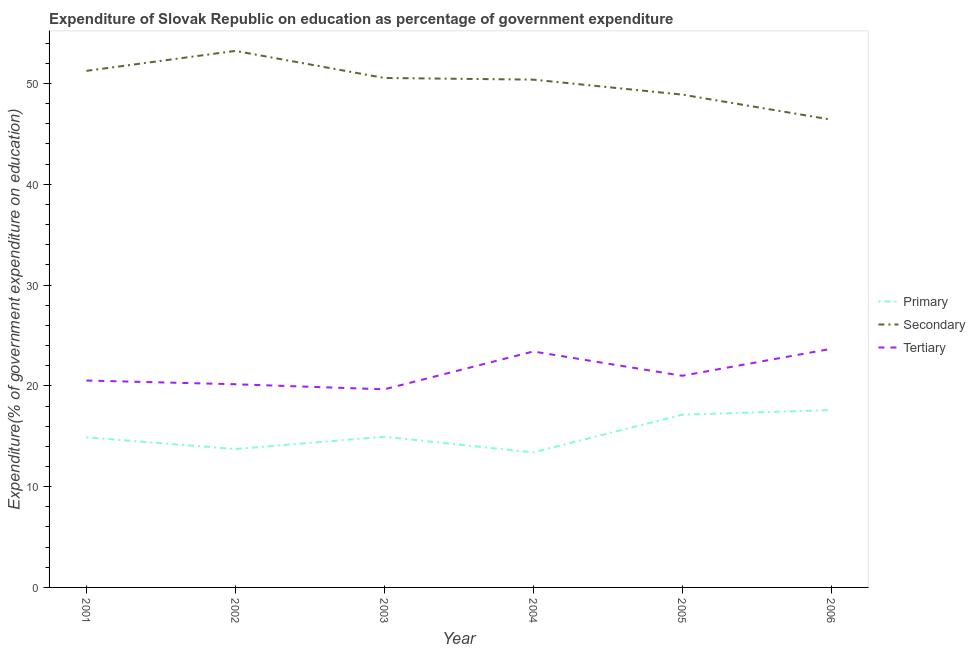Does the line corresponding to expenditure on tertiary education intersect with the line corresponding to expenditure on secondary education?
Make the answer very short. No. Is the number of lines equal to the number of legend labels?
Give a very brief answer. Yes. What is the expenditure on primary education in 2004?
Keep it short and to the point. 13.4. Across all years, what is the maximum expenditure on primary education?
Give a very brief answer. 17.6. Across all years, what is the minimum expenditure on secondary education?
Your answer should be very brief. 46.42. In which year was the expenditure on primary education minimum?
Provide a short and direct response. 2004. What is the total expenditure on tertiary education in the graph?
Offer a very short reply. 128.44. What is the difference between the expenditure on secondary education in 2002 and that in 2004?
Provide a short and direct response. 2.85. What is the difference between the expenditure on tertiary education in 2001 and the expenditure on secondary education in 2002?
Ensure brevity in your answer.  -32.71. What is the average expenditure on secondary education per year?
Provide a succinct answer. 50.12. In the year 2002, what is the difference between the expenditure on tertiary education and expenditure on secondary education?
Offer a terse response. -33.08. In how many years, is the expenditure on primary education greater than 14 %?
Your answer should be compact. 4. What is the ratio of the expenditure on secondary education in 2005 to that in 2006?
Your response must be concise. 1.05. What is the difference between the highest and the second highest expenditure on secondary education?
Ensure brevity in your answer.  1.98. What is the difference between the highest and the lowest expenditure on tertiary education?
Offer a very short reply. 4.02. Is the sum of the expenditure on tertiary education in 2004 and 2005 greater than the maximum expenditure on primary education across all years?
Provide a succinct answer. Yes. What is the difference between two consecutive major ticks on the Y-axis?
Provide a succinct answer. 10. Are the values on the major ticks of Y-axis written in scientific E-notation?
Your response must be concise. No. Does the graph contain grids?
Give a very brief answer. No. Where does the legend appear in the graph?
Keep it short and to the point. Center right. How are the legend labels stacked?
Make the answer very short. Vertical. What is the title of the graph?
Make the answer very short. Expenditure of Slovak Republic on education as percentage of government expenditure. What is the label or title of the Y-axis?
Provide a succinct answer. Expenditure(% of government expenditure on education). What is the Expenditure(% of government expenditure on education) in Primary in 2001?
Offer a terse response. 14.89. What is the Expenditure(% of government expenditure on education) of Secondary in 2001?
Your answer should be very brief. 51.26. What is the Expenditure(% of government expenditure on education) of Tertiary in 2001?
Offer a terse response. 20.53. What is the Expenditure(% of government expenditure on education) in Primary in 2002?
Ensure brevity in your answer.  13.73. What is the Expenditure(% of government expenditure on education) in Secondary in 2002?
Your response must be concise. 53.24. What is the Expenditure(% of government expenditure on education) in Tertiary in 2002?
Offer a terse response. 20.16. What is the Expenditure(% of government expenditure on education) in Primary in 2003?
Provide a succinct answer. 14.95. What is the Expenditure(% of government expenditure on education) in Secondary in 2003?
Provide a short and direct response. 50.55. What is the Expenditure(% of government expenditure on education) in Tertiary in 2003?
Your response must be concise. 19.66. What is the Expenditure(% of government expenditure on education) in Primary in 2004?
Your response must be concise. 13.4. What is the Expenditure(% of government expenditure on education) of Secondary in 2004?
Your answer should be compact. 50.39. What is the Expenditure(% of government expenditure on education) of Tertiary in 2004?
Keep it short and to the point. 23.41. What is the Expenditure(% of government expenditure on education) of Primary in 2005?
Your answer should be very brief. 17.14. What is the Expenditure(% of government expenditure on education) in Secondary in 2005?
Your answer should be very brief. 48.9. What is the Expenditure(% of government expenditure on education) in Tertiary in 2005?
Offer a very short reply. 21. What is the Expenditure(% of government expenditure on education) of Primary in 2006?
Your response must be concise. 17.6. What is the Expenditure(% of government expenditure on education) in Secondary in 2006?
Offer a terse response. 46.42. What is the Expenditure(% of government expenditure on education) of Tertiary in 2006?
Offer a very short reply. 23.68. Across all years, what is the maximum Expenditure(% of government expenditure on education) of Primary?
Offer a terse response. 17.6. Across all years, what is the maximum Expenditure(% of government expenditure on education) of Secondary?
Your answer should be compact. 53.24. Across all years, what is the maximum Expenditure(% of government expenditure on education) of Tertiary?
Provide a succinct answer. 23.68. Across all years, what is the minimum Expenditure(% of government expenditure on education) of Primary?
Your response must be concise. 13.4. Across all years, what is the minimum Expenditure(% of government expenditure on education) of Secondary?
Keep it short and to the point. 46.42. Across all years, what is the minimum Expenditure(% of government expenditure on education) of Tertiary?
Give a very brief answer. 19.66. What is the total Expenditure(% of government expenditure on education) of Primary in the graph?
Offer a very short reply. 91.71. What is the total Expenditure(% of government expenditure on education) of Secondary in the graph?
Your response must be concise. 300.74. What is the total Expenditure(% of government expenditure on education) in Tertiary in the graph?
Keep it short and to the point. 128.44. What is the difference between the Expenditure(% of government expenditure on education) of Primary in 2001 and that in 2002?
Your answer should be compact. 1.16. What is the difference between the Expenditure(% of government expenditure on education) in Secondary in 2001 and that in 2002?
Offer a terse response. -1.98. What is the difference between the Expenditure(% of government expenditure on education) of Tertiary in 2001 and that in 2002?
Provide a succinct answer. 0.37. What is the difference between the Expenditure(% of government expenditure on education) of Primary in 2001 and that in 2003?
Offer a very short reply. -0.06. What is the difference between the Expenditure(% of government expenditure on education) in Secondary in 2001 and that in 2003?
Your response must be concise. 0.7. What is the difference between the Expenditure(% of government expenditure on education) of Tertiary in 2001 and that in 2003?
Provide a short and direct response. 0.87. What is the difference between the Expenditure(% of government expenditure on education) of Primary in 2001 and that in 2004?
Your answer should be compact. 1.5. What is the difference between the Expenditure(% of government expenditure on education) in Secondary in 2001 and that in 2004?
Your answer should be compact. 0.87. What is the difference between the Expenditure(% of government expenditure on education) in Tertiary in 2001 and that in 2004?
Provide a short and direct response. -2.88. What is the difference between the Expenditure(% of government expenditure on education) in Primary in 2001 and that in 2005?
Provide a short and direct response. -2.25. What is the difference between the Expenditure(% of government expenditure on education) in Secondary in 2001 and that in 2005?
Provide a short and direct response. 2.36. What is the difference between the Expenditure(% of government expenditure on education) in Tertiary in 2001 and that in 2005?
Give a very brief answer. -0.47. What is the difference between the Expenditure(% of government expenditure on education) in Primary in 2001 and that in 2006?
Offer a very short reply. -2.71. What is the difference between the Expenditure(% of government expenditure on education) in Secondary in 2001 and that in 2006?
Your response must be concise. 4.84. What is the difference between the Expenditure(% of government expenditure on education) of Tertiary in 2001 and that in 2006?
Your answer should be very brief. -3.15. What is the difference between the Expenditure(% of government expenditure on education) of Primary in 2002 and that in 2003?
Give a very brief answer. -1.22. What is the difference between the Expenditure(% of government expenditure on education) of Secondary in 2002 and that in 2003?
Ensure brevity in your answer.  2.69. What is the difference between the Expenditure(% of government expenditure on education) in Tertiary in 2002 and that in 2003?
Your response must be concise. 0.5. What is the difference between the Expenditure(% of government expenditure on education) of Primary in 2002 and that in 2004?
Your answer should be very brief. 0.33. What is the difference between the Expenditure(% of government expenditure on education) of Secondary in 2002 and that in 2004?
Your response must be concise. 2.85. What is the difference between the Expenditure(% of government expenditure on education) in Tertiary in 2002 and that in 2004?
Your answer should be compact. -3.25. What is the difference between the Expenditure(% of government expenditure on education) of Primary in 2002 and that in 2005?
Give a very brief answer. -3.41. What is the difference between the Expenditure(% of government expenditure on education) in Secondary in 2002 and that in 2005?
Your answer should be compact. 4.34. What is the difference between the Expenditure(% of government expenditure on education) in Tertiary in 2002 and that in 2005?
Keep it short and to the point. -0.84. What is the difference between the Expenditure(% of government expenditure on education) of Primary in 2002 and that in 2006?
Give a very brief answer. -3.87. What is the difference between the Expenditure(% of government expenditure on education) of Secondary in 2002 and that in 2006?
Your response must be concise. 6.82. What is the difference between the Expenditure(% of government expenditure on education) in Tertiary in 2002 and that in 2006?
Your answer should be compact. -3.52. What is the difference between the Expenditure(% of government expenditure on education) of Primary in 2003 and that in 2004?
Offer a terse response. 1.55. What is the difference between the Expenditure(% of government expenditure on education) of Secondary in 2003 and that in 2004?
Your answer should be very brief. 0.17. What is the difference between the Expenditure(% of government expenditure on education) of Tertiary in 2003 and that in 2004?
Offer a terse response. -3.75. What is the difference between the Expenditure(% of government expenditure on education) of Primary in 2003 and that in 2005?
Provide a short and direct response. -2.19. What is the difference between the Expenditure(% of government expenditure on education) in Secondary in 2003 and that in 2005?
Your response must be concise. 1.65. What is the difference between the Expenditure(% of government expenditure on education) in Tertiary in 2003 and that in 2005?
Ensure brevity in your answer.  -1.34. What is the difference between the Expenditure(% of government expenditure on education) of Primary in 2003 and that in 2006?
Make the answer very short. -2.65. What is the difference between the Expenditure(% of government expenditure on education) in Secondary in 2003 and that in 2006?
Your answer should be very brief. 4.14. What is the difference between the Expenditure(% of government expenditure on education) in Tertiary in 2003 and that in 2006?
Offer a terse response. -4.02. What is the difference between the Expenditure(% of government expenditure on education) of Primary in 2004 and that in 2005?
Offer a very short reply. -3.74. What is the difference between the Expenditure(% of government expenditure on education) in Secondary in 2004 and that in 2005?
Keep it short and to the point. 1.49. What is the difference between the Expenditure(% of government expenditure on education) of Tertiary in 2004 and that in 2005?
Provide a short and direct response. 2.41. What is the difference between the Expenditure(% of government expenditure on education) of Primary in 2004 and that in 2006?
Provide a short and direct response. -4.2. What is the difference between the Expenditure(% of government expenditure on education) in Secondary in 2004 and that in 2006?
Your answer should be very brief. 3.97. What is the difference between the Expenditure(% of government expenditure on education) of Tertiary in 2004 and that in 2006?
Give a very brief answer. -0.26. What is the difference between the Expenditure(% of government expenditure on education) of Primary in 2005 and that in 2006?
Your answer should be compact. -0.46. What is the difference between the Expenditure(% of government expenditure on education) of Secondary in 2005 and that in 2006?
Ensure brevity in your answer.  2.48. What is the difference between the Expenditure(% of government expenditure on education) in Tertiary in 2005 and that in 2006?
Your answer should be very brief. -2.67. What is the difference between the Expenditure(% of government expenditure on education) of Primary in 2001 and the Expenditure(% of government expenditure on education) of Secondary in 2002?
Your response must be concise. -38.34. What is the difference between the Expenditure(% of government expenditure on education) in Primary in 2001 and the Expenditure(% of government expenditure on education) in Tertiary in 2002?
Your answer should be very brief. -5.27. What is the difference between the Expenditure(% of government expenditure on education) in Secondary in 2001 and the Expenditure(% of government expenditure on education) in Tertiary in 2002?
Your answer should be very brief. 31.1. What is the difference between the Expenditure(% of government expenditure on education) of Primary in 2001 and the Expenditure(% of government expenditure on education) of Secondary in 2003?
Your answer should be compact. -35.66. What is the difference between the Expenditure(% of government expenditure on education) in Primary in 2001 and the Expenditure(% of government expenditure on education) in Tertiary in 2003?
Provide a short and direct response. -4.76. What is the difference between the Expenditure(% of government expenditure on education) in Secondary in 2001 and the Expenditure(% of government expenditure on education) in Tertiary in 2003?
Provide a succinct answer. 31.6. What is the difference between the Expenditure(% of government expenditure on education) of Primary in 2001 and the Expenditure(% of government expenditure on education) of Secondary in 2004?
Make the answer very short. -35.49. What is the difference between the Expenditure(% of government expenditure on education) of Primary in 2001 and the Expenditure(% of government expenditure on education) of Tertiary in 2004?
Keep it short and to the point. -8.52. What is the difference between the Expenditure(% of government expenditure on education) in Secondary in 2001 and the Expenditure(% of government expenditure on education) in Tertiary in 2004?
Offer a terse response. 27.84. What is the difference between the Expenditure(% of government expenditure on education) of Primary in 2001 and the Expenditure(% of government expenditure on education) of Secondary in 2005?
Give a very brief answer. -34.01. What is the difference between the Expenditure(% of government expenditure on education) of Primary in 2001 and the Expenditure(% of government expenditure on education) of Tertiary in 2005?
Ensure brevity in your answer.  -6.11. What is the difference between the Expenditure(% of government expenditure on education) of Secondary in 2001 and the Expenditure(% of government expenditure on education) of Tertiary in 2005?
Your response must be concise. 30.25. What is the difference between the Expenditure(% of government expenditure on education) of Primary in 2001 and the Expenditure(% of government expenditure on education) of Secondary in 2006?
Your response must be concise. -31.52. What is the difference between the Expenditure(% of government expenditure on education) of Primary in 2001 and the Expenditure(% of government expenditure on education) of Tertiary in 2006?
Give a very brief answer. -8.78. What is the difference between the Expenditure(% of government expenditure on education) in Secondary in 2001 and the Expenditure(% of government expenditure on education) in Tertiary in 2006?
Your answer should be compact. 27.58. What is the difference between the Expenditure(% of government expenditure on education) of Primary in 2002 and the Expenditure(% of government expenditure on education) of Secondary in 2003?
Your answer should be compact. -36.82. What is the difference between the Expenditure(% of government expenditure on education) in Primary in 2002 and the Expenditure(% of government expenditure on education) in Tertiary in 2003?
Offer a terse response. -5.93. What is the difference between the Expenditure(% of government expenditure on education) in Secondary in 2002 and the Expenditure(% of government expenditure on education) in Tertiary in 2003?
Your answer should be compact. 33.58. What is the difference between the Expenditure(% of government expenditure on education) of Primary in 2002 and the Expenditure(% of government expenditure on education) of Secondary in 2004?
Your answer should be compact. -36.66. What is the difference between the Expenditure(% of government expenditure on education) of Primary in 2002 and the Expenditure(% of government expenditure on education) of Tertiary in 2004?
Give a very brief answer. -9.68. What is the difference between the Expenditure(% of government expenditure on education) in Secondary in 2002 and the Expenditure(% of government expenditure on education) in Tertiary in 2004?
Your response must be concise. 29.82. What is the difference between the Expenditure(% of government expenditure on education) in Primary in 2002 and the Expenditure(% of government expenditure on education) in Secondary in 2005?
Provide a succinct answer. -35.17. What is the difference between the Expenditure(% of government expenditure on education) of Primary in 2002 and the Expenditure(% of government expenditure on education) of Tertiary in 2005?
Your answer should be compact. -7.27. What is the difference between the Expenditure(% of government expenditure on education) of Secondary in 2002 and the Expenditure(% of government expenditure on education) of Tertiary in 2005?
Make the answer very short. 32.24. What is the difference between the Expenditure(% of government expenditure on education) in Primary in 2002 and the Expenditure(% of government expenditure on education) in Secondary in 2006?
Make the answer very short. -32.69. What is the difference between the Expenditure(% of government expenditure on education) in Primary in 2002 and the Expenditure(% of government expenditure on education) in Tertiary in 2006?
Your response must be concise. -9.95. What is the difference between the Expenditure(% of government expenditure on education) in Secondary in 2002 and the Expenditure(% of government expenditure on education) in Tertiary in 2006?
Provide a succinct answer. 29.56. What is the difference between the Expenditure(% of government expenditure on education) of Primary in 2003 and the Expenditure(% of government expenditure on education) of Secondary in 2004?
Offer a very short reply. -35.44. What is the difference between the Expenditure(% of government expenditure on education) of Primary in 2003 and the Expenditure(% of government expenditure on education) of Tertiary in 2004?
Your answer should be compact. -8.46. What is the difference between the Expenditure(% of government expenditure on education) of Secondary in 2003 and the Expenditure(% of government expenditure on education) of Tertiary in 2004?
Offer a terse response. 27.14. What is the difference between the Expenditure(% of government expenditure on education) of Primary in 2003 and the Expenditure(% of government expenditure on education) of Secondary in 2005?
Make the answer very short. -33.95. What is the difference between the Expenditure(% of government expenditure on education) in Primary in 2003 and the Expenditure(% of government expenditure on education) in Tertiary in 2005?
Provide a succinct answer. -6.05. What is the difference between the Expenditure(% of government expenditure on education) in Secondary in 2003 and the Expenditure(% of government expenditure on education) in Tertiary in 2005?
Your response must be concise. 29.55. What is the difference between the Expenditure(% of government expenditure on education) in Primary in 2003 and the Expenditure(% of government expenditure on education) in Secondary in 2006?
Offer a terse response. -31.47. What is the difference between the Expenditure(% of government expenditure on education) of Primary in 2003 and the Expenditure(% of government expenditure on education) of Tertiary in 2006?
Keep it short and to the point. -8.73. What is the difference between the Expenditure(% of government expenditure on education) of Secondary in 2003 and the Expenditure(% of government expenditure on education) of Tertiary in 2006?
Provide a short and direct response. 26.88. What is the difference between the Expenditure(% of government expenditure on education) of Primary in 2004 and the Expenditure(% of government expenditure on education) of Secondary in 2005?
Offer a very short reply. -35.5. What is the difference between the Expenditure(% of government expenditure on education) in Primary in 2004 and the Expenditure(% of government expenditure on education) in Tertiary in 2005?
Keep it short and to the point. -7.6. What is the difference between the Expenditure(% of government expenditure on education) in Secondary in 2004 and the Expenditure(% of government expenditure on education) in Tertiary in 2005?
Your answer should be very brief. 29.38. What is the difference between the Expenditure(% of government expenditure on education) in Primary in 2004 and the Expenditure(% of government expenditure on education) in Secondary in 2006?
Offer a terse response. -33.02. What is the difference between the Expenditure(% of government expenditure on education) in Primary in 2004 and the Expenditure(% of government expenditure on education) in Tertiary in 2006?
Offer a terse response. -10.28. What is the difference between the Expenditure(% of government expenditure on education) of Secondary in 2004 and the Expenditure(% of government expenditure on education) of Tertiary in 2006?
Make the answer very short. 26.71. What is the difference between the Expenditure(% of government expenditure on education) in Primary in 2005 and the Expenditure(% of government expenditure on education) in Secondary in 2006?
Your answer should be compact. -29.28. What is the difference between the Expenditure(% of government expenditure on education) in Primary in 2005 and the Expenditure(% of government expenditure on education) in Tertiary in 2006?
Make the answer very short. -6.54. What is the difference between the Expenditure(% of government expenditure on education) in Secondary in 2005 and the Expenditure(% of government expenditure on education) in Tertiary in 2006?
Offer a terse response. 25.22. What is the average Expenditure(% of government expenditure on education) of Primary per year?
Your response must be concise. 15.29. What is the average Expenditure(% of government expenditure on education) in Secondary per year?
Provide a succinct answer. 50.12. What is the average Expenditure(% of government expenditure on education) in Tertiary per year?
Your response must be concise. 21.41. In the year 2001, what is the difference between the Expenditure(% of government expenditure on education) in Primary and Expenditure(% of government expenditure on education) in Secondary?
Ensure brevity in your answer.  -36.36. In the year 2001, what is the difference between the Expenditure(% of government expenditure on education) in Primary and Expenditure(% of government expenditure on education) in Tertiary?
Provide a short and direct response. -5.63. In the year 2001, what is the difference between the Expenditure(% of government expenditure on education) in Secondary and Expenditure(% of government expenditure on education) in Tertiary?
Your answer should be very brief. 30.73. In the year 2002, what is the difference between the Expenditure(% of government expenditure on education) of Primary and Expenditure(% of government expenditure on education) of Secondary?
Offer a terse response. -39.51. In the year 2002, what is the difference between the Expenditure(% of government expenditure on education) of Primary and Expenditure(% of government expenditure on education) of Tertiary?
Give a very brief answer. -6.43. In the year 2002, what is the difference between the Expenditure(% of government expenditure on education) of Secondary and Expenditure(% of government expenditure on education) of Tertiary?
Make the answer very short. 33.08. In the year 2003, what is the difference between the Expenditure(% of government expenditure on education) in Primary and Expenditure(% of government expenditure on education) in Secondary?
Make the answer very short. -35.6. In the year 2003, what is the difference between the Expenditure(% of government expenditure on education) of Primary and Expenditure(% of government expenditure on education) of Tertiary?
Your response must be concise. -4.71. In the year 2003, what is the difference between the Expenditure(% of government expenditure on education) of Secondary and Expenditure(% of government expenditure on education) of Tertiary?
Ensure brevity in your answer.  30.89. In the year 2004, what is the difference between the Expenditure(% of government expenditure on education) in Primary and Expenditure(% of government expenditure on education) in Secondary?
Provide a short and direct response. -36.99. In the year 2004, what is the difference between the Expenditure(% of government expenditure on education) in Primary and Expenditure(% of government expenditure on education) in Tertiary?
Provide a short and direct response. -10.01. In the year 2004, what is the difference between the Expenditure(% of government expenditure on education) of Secondary and Expenditure(% of government expenditure on education) of Tertiary?
Your answer should be compact. 26.97. In the year 2005, what is the difference between the Expenditure(% of government expenditure on education) of Primary and Expenditure(% of government expenditure on education) of Secondary?
Offer a very short reply. -31.76. In the year 2005, what is the difference between the Expenditure(% of government expenditure on education) in Primary and Expenditure(% of government expenditure on education) in Tertiary?
Provide a succinct answer. -3.86. In the year 2005, what is the difference between the Expenditure(% of government expenditure on education) in Secondary and Expenditure(% of government expenditure on education) in Tertiary?
Offer a very short reply. 27.9. In the year 2006, what is the difference between the Expenditure(% of government expenditure on education) in Primary and Expenditure(% of government expenditure on education) in Secondary?
Your answer should be compact. -28.82. In the year 2006, what is the difference between the Expenditure(% of government expenditure on education) of Primary and Expenditure(% of government expenditure on education) of Tertiary?
Give a very brief answer. -6.08. In the year 2006, what is the difference between the Expenditure(% of government expenditure on education) of Secondary and Expenditure(% of government expenditure on education) of Tertiary?
Keep it short and to the point. 22.74. What is the ratio of the Expenditure(% of government expenditure on education) of Primary in 2001 to that in 2002?
Offer a very short reply. 1.08. What is the ratio of the Expenditure(% of government expenditure on education) in Secondary in 2001 to that in 2002?
Give a very brief answer. 0.96. What is the ratio of the Expenditure(% of government expenditure on education) in Tertiary in 2001 to that in 2002?
Give a very brief answer. 1.02. What is the ratio of the Expenditure(% of government expenditure on education) of Primary in 2001 to that in 2003?
Ensure brevity in your answer.  1. What is the ratio of the Expenditure(% of government expenditure on education) of Secondary in 2001 to that in 2003?
Make the answer very short. 1.01. What is the ratio of the Expenditure(% of government expenditure on education) of Tertiary in 2001 to that in 2003?
Ensure brevity in your answer.  1.04. What is the ratio of the Expenditure(% of government expenditure on education) of Primary in 2001 to that in 2004?
Keep it short and to the point. 1.11. What is the ratio of the Expenditure(% of government expenditure on education) in Secondary in 2001 to that in 2004?
Offer a very short reply. 1.02. What is the ratio of the Expenditure(% of government expenditure on education) in Tertiary in 2001 to that in 2004?
Offer a very short reply. 0.88. What is the ratio of the Expenditure(% of government expenditure on education) of Primary in 2001 to that in 2005?
Provide a succinct answer. 0.87. What is the ratio of the Expenditure(% of government expenditure on education) of Secondary in 2001 to that in 2005?
Offer a terse response. 1.05. What is the ratio of the Expenditure(% of government expenditure on education) of Tertiary in 2001 to that in 2005?
Ensure brevity in your answer.  0.98. What is the ratio of the Expenditure(% of government expenditure on education) in Primary in 2001 to that in 2006?
Your answer should be compact. 0.85. What is the ratio of the Expenditure(% of government expenditure on education) of Secondary in 2001 to that in 2006?
Keep it short and to the point. 1.1. What is the ratio of the Expenditure(% of government expenditure on education) in Tertiary in 2001 to that in 2006?
Offer a very short reply. 0.87. What is the ratio of the Expenditure(% of government expenditure on education) of Primary in 2002 to that in 2003?
Make the answer very short. 0.92. What is the ratio of the Expenditure(% of government expenditure on education) of Secondary in 2002 to that in 2003?
Give a very brief answer. 1.05. What is the ratio of the Expenditure(% of government expenditure on education) of Tertiary in 2002 to that in 2003?
Offer a very short reply. 1.03. What is the ratio of the Expenditure(% of government expenditure on education) in Primary in 2002 to that in 2004?
Provide a succinct answer. 1.02. What is the ratio of the Expenditure(% of government expenditure on education) of Secondary in 2002 to that in 2004?
Make the answer very short. 1.06. What is the ratio of the Expenditure(% of government expenditure on education) in Tertiary in 2002 to that in 2004?
Your answer should be compact. 0.86. What is the ratio of the Expenditure(% of government expenditure on education) in Primary in 2002 to that in 2005?
Your answer should be very brief. 0.8. What is the ratio of the Expenditure(% of government expenditure on education) in Secondary in 2002 to that in 2005?
Provide a short and direct response. 1.09. What is the ratio of the Expenditure(% of government expenditure on education) in Tertiary in 2002 to that in 2005?
Ensure brevity in your answer.  0.96. What is the ratio of the Expenditure(% of government expenditure on education) of Primary in 2002 to that in 2006?
Keep it short and to the point. 0.78. What is the ratio of the Expenditure(% of government expenditure on education) in Secondary in 2002 to that in 2006?
Your answer should be compact. 1.15. What is the ratio of the Expenditure(% of government expenditure on education) of Tertiary in 2002 to that in 2006?
Your response must be concise. 0.85. What is the ratio of the Expenditure(% of government expenditure on education) of Primary in 2003 to that in 2004?
Your response must be concise. 1.12. What is the ratio of the Expenditure(% of government expenditure on education) in Secondary in 2003 to that in 2004?
Provide a short and direct response. 1. What is the ratio of the Expenditure(% of government expenditure on education) of Tertiary in 2003 to that in 2004?
Your answer should be compact. 0.84. What is the ratio of the Expenditure(% of government expenditure on education) of Primary in 2003 to that in 2005?
Offer a very short reply. 0.87. What is the ratio of the Expenditure(% of government expenditure on education) of Secondary in 2003 to that in 2005?
Provide a short and direct response. 1.03. What is the ratio of the Expenditure(% of government expenditure on education) of Tertiary in 2003 to that in 2005?
Your response must be concise. 0.94. What is the ratio of the Expenditure(% of government expenditure on education) in Primary in 2003 to that in 2006?
Provide a succinct answer. 0.85. What is the ratio of the Expenditure(% of government expenditure on education) in Secondary in 2003 to that in 2006?
Provide a short and direct response. 1.09. What is the ratio of the Expenditure(% of government expenditure on education) in Tertiary in 2003 to that in 2006?
Give a very brief answer. 0.83. What is the ratio of the Expenditure(% of government expenditure on education) of Primary in 2004 to that in 2005?
Offer a terse response. 0.78. What is the ratio of the Expenditure(% of government expenditure on education) in Secondary in 2004 to that in 2005?
Your answer should be compact. 1.03. What is the ratio of the Expenditure(% of government expenditure on education) of Tertiary in 2004 to that in 2005?
Give a very brief answer. 1.11. What is the ratio of the Expenditure(% of government expenditure on education) in Primary in 2004 to that in 2006?
Your answer should be very brief. 0.76. What is the ratio of the Expenditure(% of government expenditure on education) of Secondary in 2004 to that in 2006?
Give a very brief answer. 1.09. What is the ratio of the Expenditure(% of government expenditure on education) in Tertiary in 2004 to that in 2006?
Your answer should be compact. 0.99. What is the ratio of the Expenditure(% of government expenditure on education) of Primary in 2005 to that in 2006?
Keep it short and to the point. 0.97. What is the ratio of the Expenditure(% of government expenditure on education) of Secondary in 2005 to that in 2006?
Offer a terse response. 1.05. What is the ratio of the Expenditure(% of government expenditure on education) of Tertiary in 2005 to that in 2006?
Ensure brevity in your answer.  0.89. What is the difference between the highest and the second highest Expenditure(% of government expenditure on education) of Primary?
Your response must be concise. 0.46. What is the difference between the highest and the second highest Expenditure(% of government expenditure on education) in Secondary?
Your answer should be compact. 1.98. What is the difference between the highest and the second highest Expenditure(% of government expenditure on education) in Tertiary?
Your answer should be compact. 0.26. What is the difference between the highest and the lowest Expenditure(% of government expenditure on education) of Primary?
Your answer should be compact. 4.2. What is the difference between the highest and the lowest Expenditure(% of government expenditure on education) in Secondary?
Your response must be concise. 6.82. What is the difference between the highest and the lowest Expenditure(% of government expenditure on education) of Tertiary?
Your answer should be very brief. 4.02. 